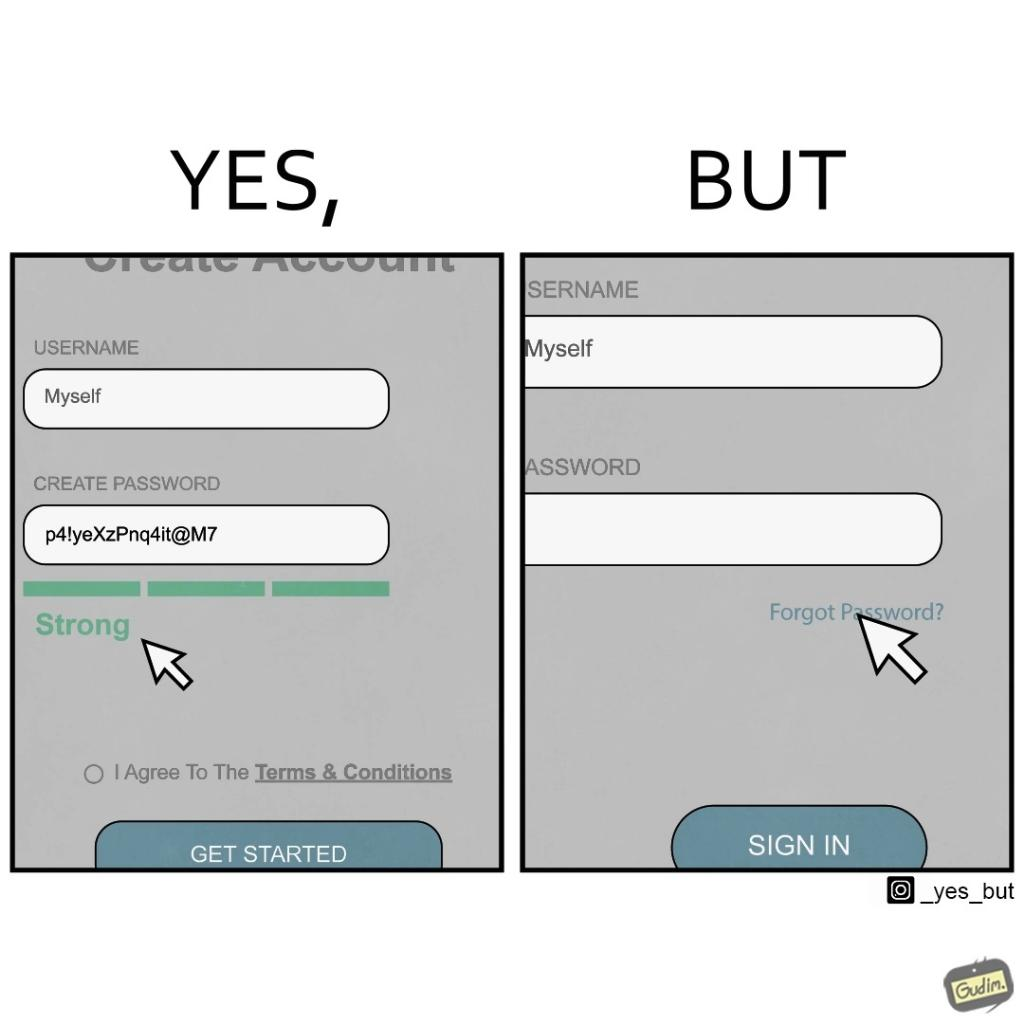Is there satirical content in this image? Yes, this image is satirical. 